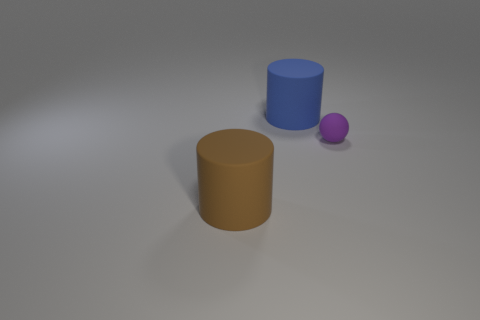Add 1 brown matte cylinders. How many objects exist? 4 Subtract all cylinders. How many objects are left? 1 Subtract all big blue rubber cylinders. Subtract all purple objects. How many objects are left? 1 Add 1 small matte objects. How many small matte objects are left? 2 Add 2 big blue spheres. How many big blue spheres exist? 2 Subtract 1 purple balls. How many objects are left? 2 